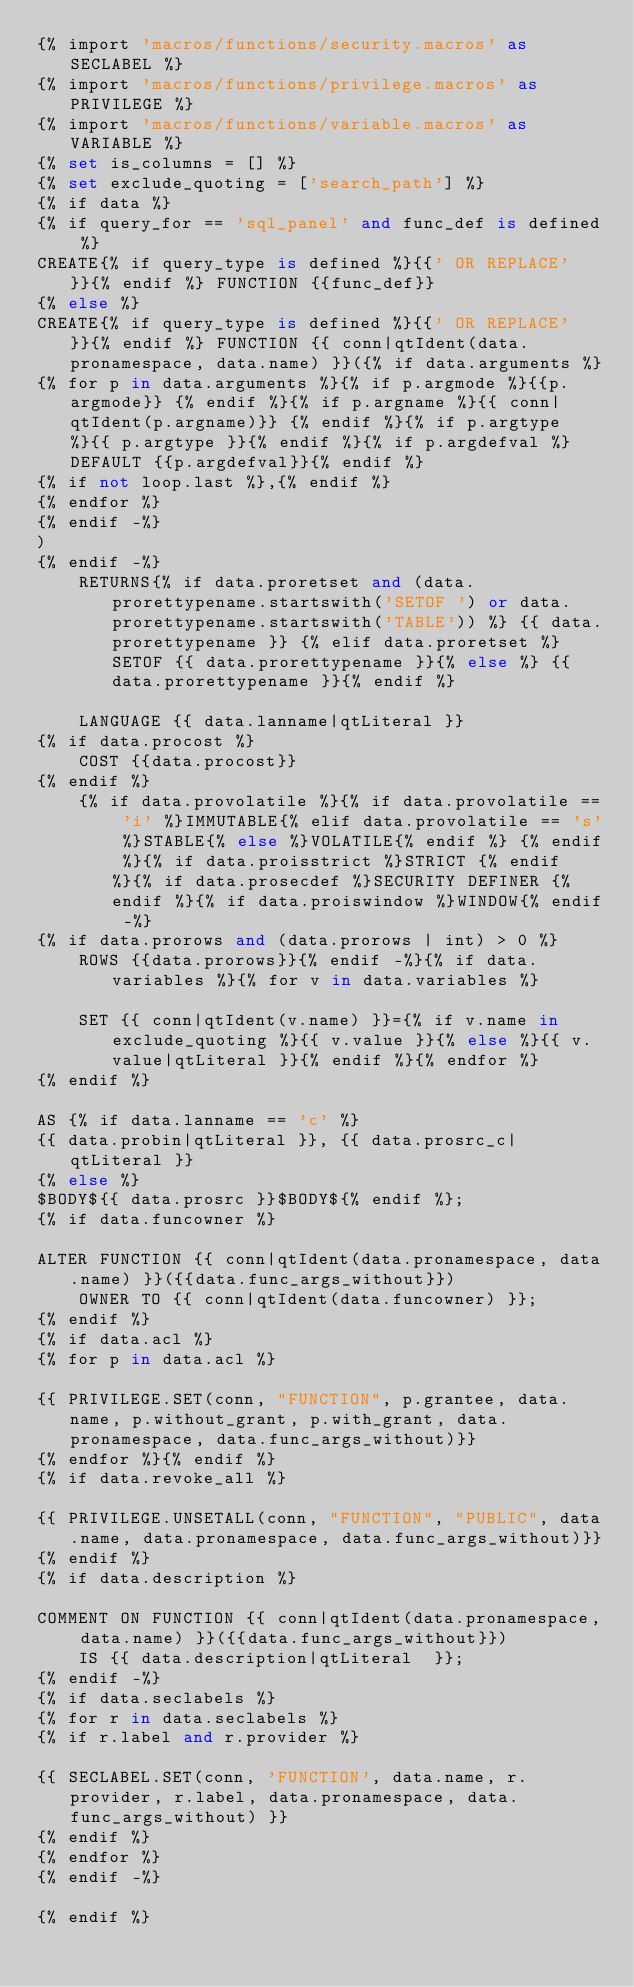Convert code to text. <code><loc_0><loc_0><loc_500><loc_500><_SQL_>{% import 'macros/functions/security.macros' as SECLABEL %}
{% import 'macros/functions/privilege.macros' as PRIVILEGE %}
{% import 'macros/functions/variable.macros' as VARIABLE %}
{% set is_columns = [] %}
{% set exclude_quoting = ['search_path'] %}
{% if data %}
{% if query_for == 'sql_panel' and func_def is defined %}
CREATE{% if query_type is defined %}{{' OR REPLACE'}}{% endif %} FUNCTION {{func_def}}
{% else %}
CREATE{% if query_type is defined %}{{' OR REPLACE'}}{% endif %} FUNCTION {{ conn|qtIdent(data.pronamespace, data.name) }}({% if data.arguments %}
{% for p in data.arguments %}{% if p.argmode %}{{p.argmode}} {% endif %}{% if p.argname %}{{ conn|qtIdent(p.argname)}} {% endif %}{% if p.argtype %}{{ p.argtype }}{% endif %}{% if p.argdefval %} DEFAULT {{p.argdefval}}{% endif %}
{% if not loop.last %},{% endif %}
{% endfor %}
{% endif -%}
)
{% endif -%}
    RETURNS{% if data.proretset and (data.prorettypename.startswith('SETOF ') or data.prorettypename.startswith('TABLE')) %} {{ data.prorettypename }} {% elif data.proretset %} SETOF {{ data.prorettypename }}{% else %} {{ data.prorettypename }}{% endif %}

    LANGUAGE {{ data.lanname|qtLiteral }}
{% if data.procost %}
    COST {{data.procost}}
{% endif %}
    {% if data.provolatile %}{% if data.provolatile == 'i' %}IMMUTABLE{% elif data.provolatile == 's' %}STABLE{% else %}VOLATILE{% endif %} {% endif %}{% if data.proisstrict %}STRICT {% endif %}{% if data.prosecdef %}SECURITY DEFINER {% endif %}{% if data.proiswindow %}WINDOW{% endif -%}
{% if data.prorows and (data.prorows | int) > 0 %}
    ROWS {{data.prorows}}{% endif -%}{% if data.variables %}{% for v in data.variables %}

    SET {{ conn|qtIdent(v.name) }}={% if v.name in exclude_quoting %}{{ v.value }}{% else %}{{ v.value|qtLiteral }}{% endif %}{% endfor %}
{% endif %}

AS {% if data.lanname == 'c' %}
{{ data.probin|qtLiteral }}, {{ data.prosrc_c|qtLiteral }}
{% else %}
$BODY${{ data.prosrc }}$BODY${% endif %};
{% if data.funcowner %}

ALTER FUNCTION {{ conn|qtIdent(data.pronamespace, data.name) }}({{data.func_args_without}})
    OWNER TO {{ conn|qtIdent(data.funcowner) }};
{% endif %}
{% if data.acl %}
{% for p in data.acl %}

{{ PRIVILEGE.SET(conn, "FUNCTION", p.grantee, data.name, p.without_grant, p.with_grant, data.pronamespace, data.func_args_without)}}
{% endfor %}{% endif %}
{% if data.revoke_all %}

{{ PRIVILEGE.UNSETALL(conn, "FUNCTION", "PUBLIC", data.name, data.pronamespace, data.func_args_without)}}
{% endif %}
{% if data.description %}

COMMENT ON FUNCTION {{ conn|qtIdent(data.pronamespace, data.name) }}({{data.func_args_without}})
    IS {{ data.description|qtLiteral  }};
{% endif -%}
{% if data.seclabels %}
{% for r in data.seclabels %}
{% if r.label and r.provider %}

{{ SECLABEL.SET(conn, 'FUNCTION', data.name, r.provider, r.label, data.pronamespace, data.func_args_without) }}
{% endif %}
{% endfor %}
{% endif -%}

{% endif %}
</code> 